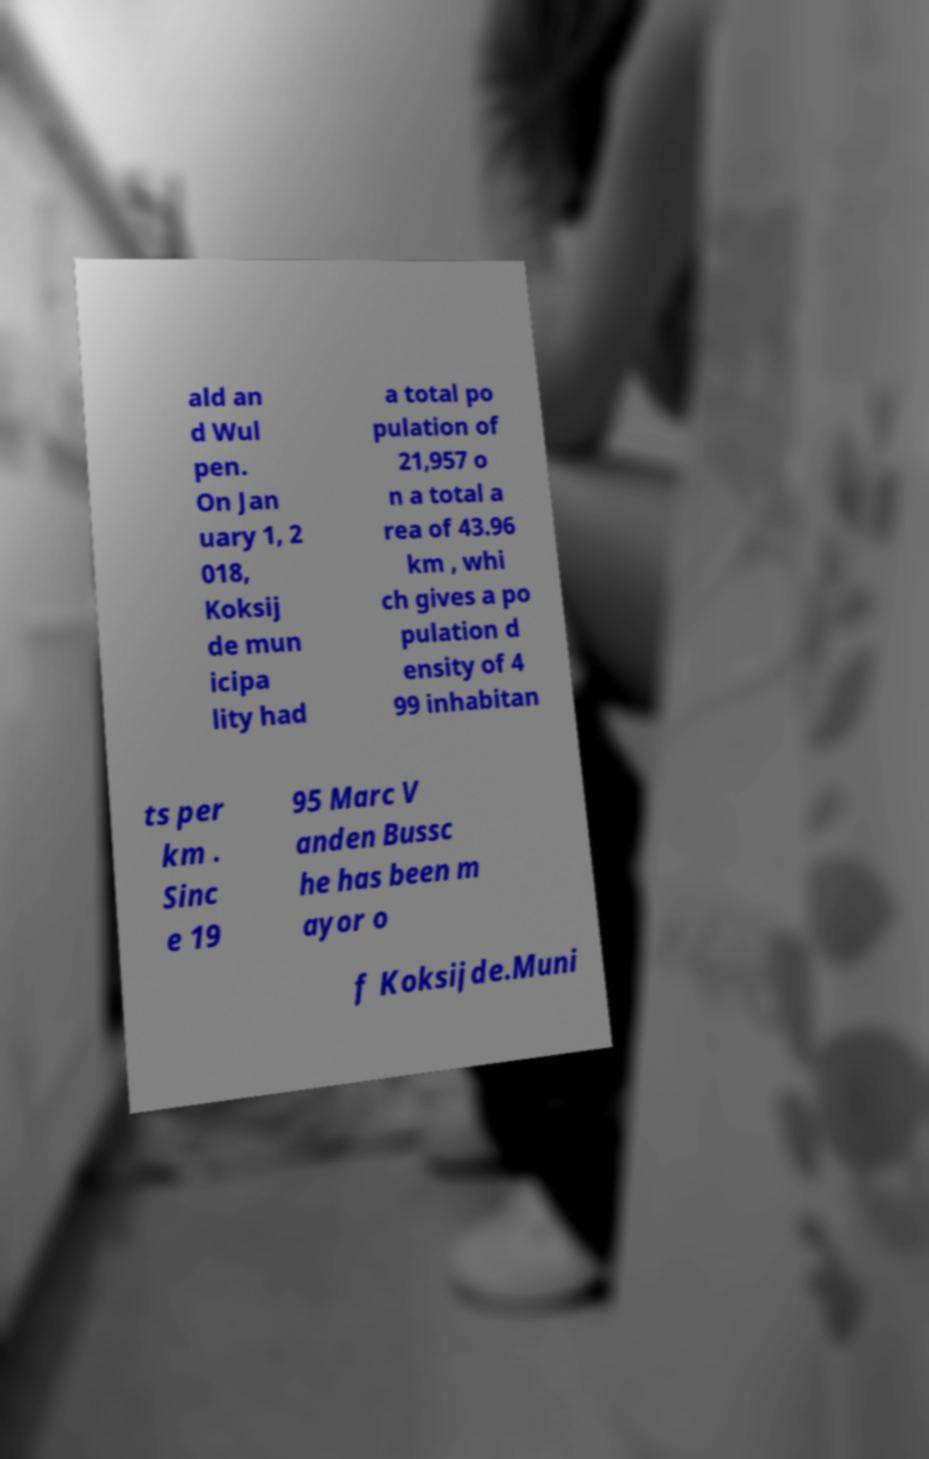Please identify and transcribe the text found in this image. ald an d Wul pen. On Jan uary 1, 2 018, Koksij de mun icipa lity had a total po pulation of 21,957 o n a total a rea of 43.96 km , whi ch gives a po pulation d ensity of 4 99 inhabitan ts per km . Sinc e 19 95 Marc V anden Bussc he has been m ayor o f Koksijde.Muni 